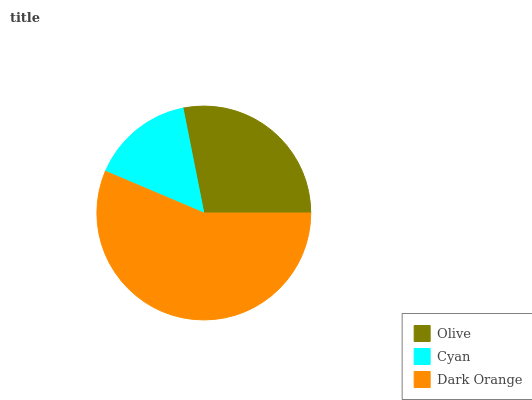Is Cyan the minimum?
Answer yes or no. Yes. Is Dark Orange the maximum?
Answer yes or no. Yes. Is Dark Orange the minimum?
Answer yes or no. No. Is Cyan the maximum?
Answer yes or no. No. Is Dark Orange greater than Cyan?
Answer yes or no. Yes. Is Cyan less than Dark Orange?
Answer yes or no. Yes. Is Cyan greater than Dark Orange?
Answer yes or no. No. Is Dark Orange less than Cyan?
Answer yes or no. No. Is Olive the high median?
Answer yes or no. Yes. Is Olive the low median?
Answer yes or no. Yes. Is Cyan the high median?
Answer yes or no. No. Is Cyan the low median?
Answer yes or no. No. 